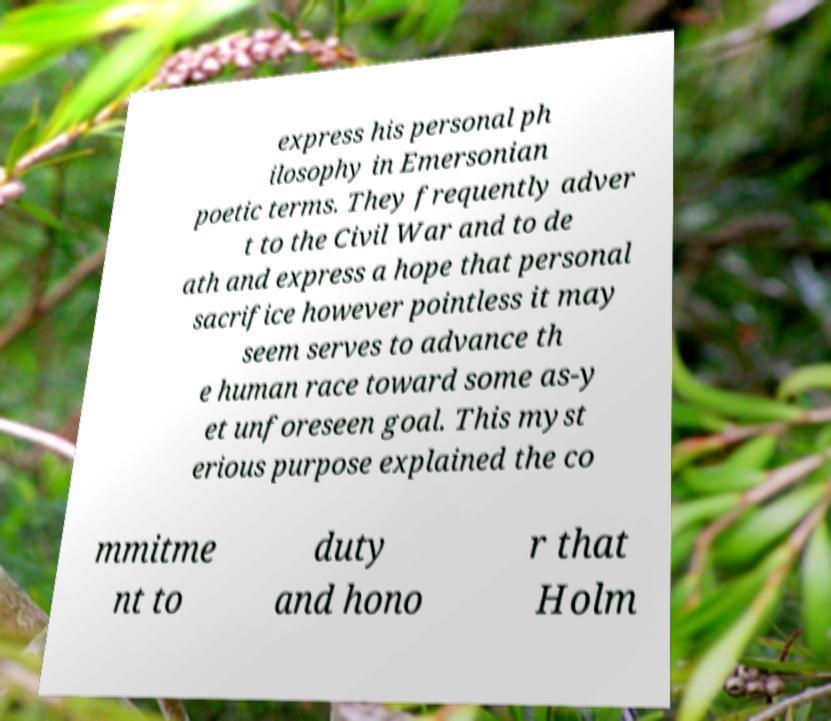Please read and relay the text visible in this image. What does it say? express his personal ph ilosophy in Emersonian poetic terms. They frequently adver t to the Civil War and to de ath and express a hope that personal sacrifice however pointless it may seem serves to advance th e human race toward some as-y et unforeseen goal. This myst erious purpose explained the co mmitme nt to duty and hono r that Holm 